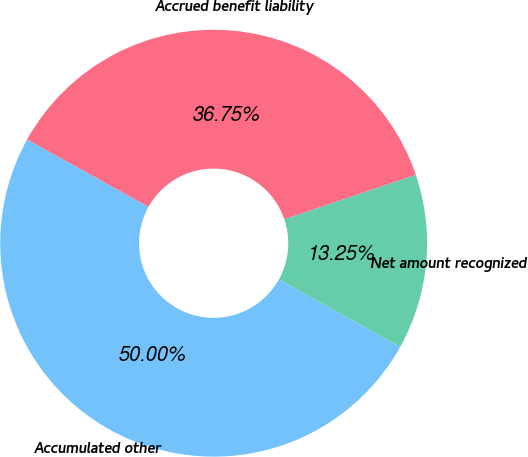Convert chart to OTSL. <chart><loc_0><loc_0><loc_500><loc_500><pie_chart><fcel>Accrued benefit liability<fcel>Accumulated other<fcel>Net amount recognized<nl><fcel>36.75%<fcel>50.0%<fcel>13.25%<nl></chart> 